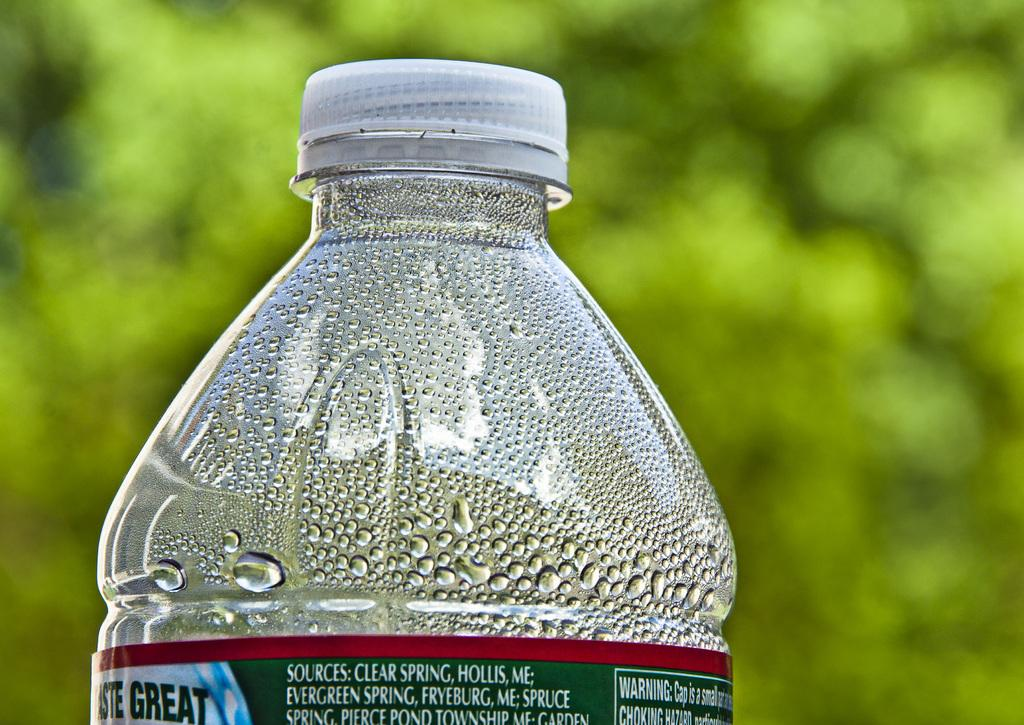<image>
Offer a succinct explanation of the picture presented. a bottle of water that has a green and blue label on it that says 'great' 